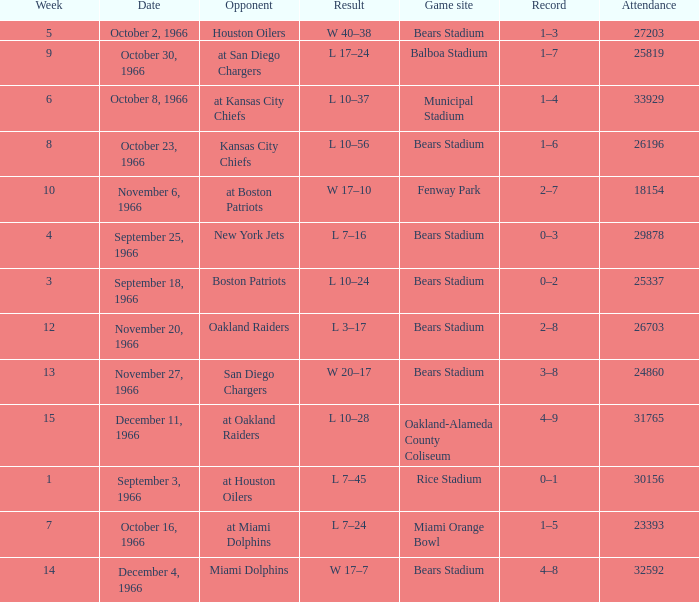I'm looking to parse the entire table for insights. Could you assist me with that? {'header': ['Week', 'Date', 'Opponent', 'Result', 'Game site', 'Record', 'Attendance'], 'rows': [['5', 'October 2, 1966', 'Houston Oilers', 'W 40–38', 'Bears Stadium', '1–3', '27203'], ['9', 'October 30, 1966', 'at San Diego Chargers', 'L 17–24', 'Balboa Stadium', '1–7', '25819'], ['6', 'October 8, 1966', 'at Kansas City Chiefs', 'L 10–37', 'Municipal Stadium', '1–4', '33929'], ['8', 'October 23, 1966', 'Kansas City Chiefs', 'L 10–56', 'Bears Stadium', '1–6', '26196'], ['10', 'November 6, 1966', 'at Boston Patriots', 'W 17–10', 'Fenway Park', '2–7', '18154'], ['4', 'September 25, 1966', 'New York Jets', 'L 7–16', 'Bears Stadium', '0–3', '29878'], ['3', 'September 18, 1966', 'Boston Patriots', 'L 10–24', 'Bears Stadium', '0–2', '25337'], ['12', 'November 20, 1966', 'Oakland Raiders', 'L 3–17', 'Bears Stadium', '2–8', '26703'], ['13', 'November 27, 1966', 'San Diego Chargers', 'W 20–17', 'Bears Stadium', '3–8', '24860'], ['15', 'December 11, 1966', 'at Oakland Raiders', 'L 10–28', 'Oakland-Alameda County Coliseum', '4–9', '31765'], ['1', 'September 3, 1966', 'at Houston Oilers', 'L 7–45', 'Rice Stadium', '0–1', '30156'], ['7', 'October 16, 1966', 'at Miami Dolphins', 'L 7–24', 'Miami Orange Bowl', '1–5', '23393'], ['14', 'December 4, 1966', 'Miami Dolphins', 'W 17–7', 'Bears Stadium', '4–8', '32592']]} How many results are listed for week 13? 1.0. 